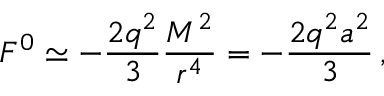<formula> <loc_0><loc_0><loc_500><loc_500>F ^ { 0 } \simeq - \frac { 2 q ^ { 2 } } 3 \frac { M ^ { 2 } } { r ^ { 4 } } = - \frac { 2 q ^ { 2 } a ^ { 2 } } 3 \, ,</formula> 